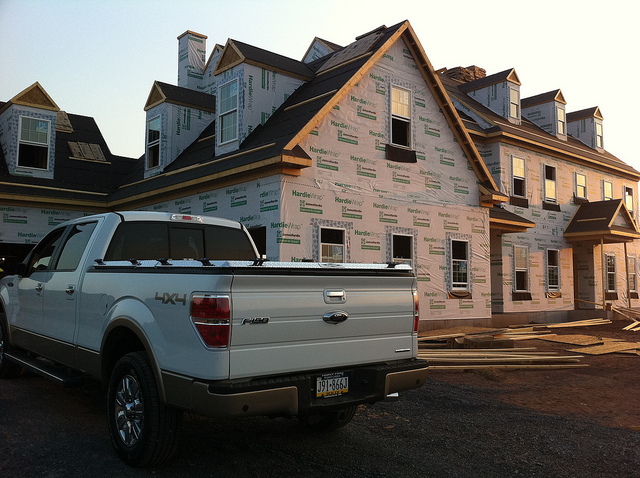Extract all visible text content from this image. J91 4X4 HNDIE 